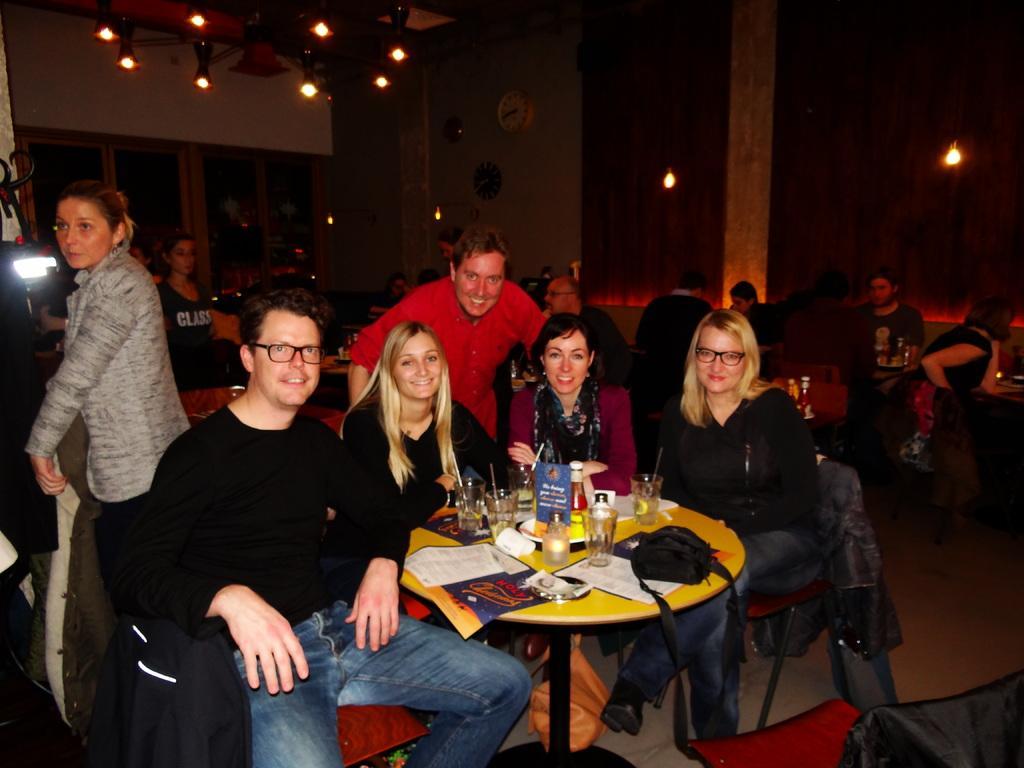In one or two sentences, can you explain what this image depicts? People are sitting in groups at tables in a restaurant. 